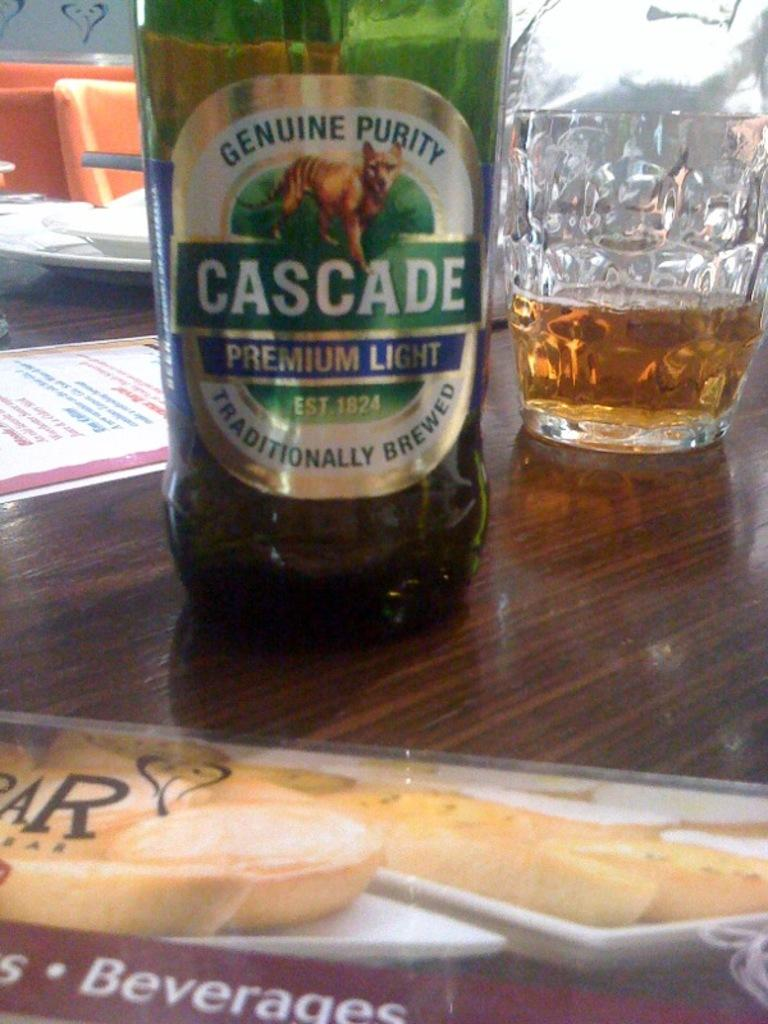What is present on the table in the image? There is a bottle and a glass on the table in the image. What might be the purpose of the bottle and the glass? The bottle and the glass might be used for holding or serving a beverage. Can you describe the location of the bottle and the glass? Both the bottle and the glass are on a table in the image. What type of glue is being used in the discussion between the bottle and the glass in the image? There is no discussion or glue present in the image; it only features a bottle and a glass on a table. 